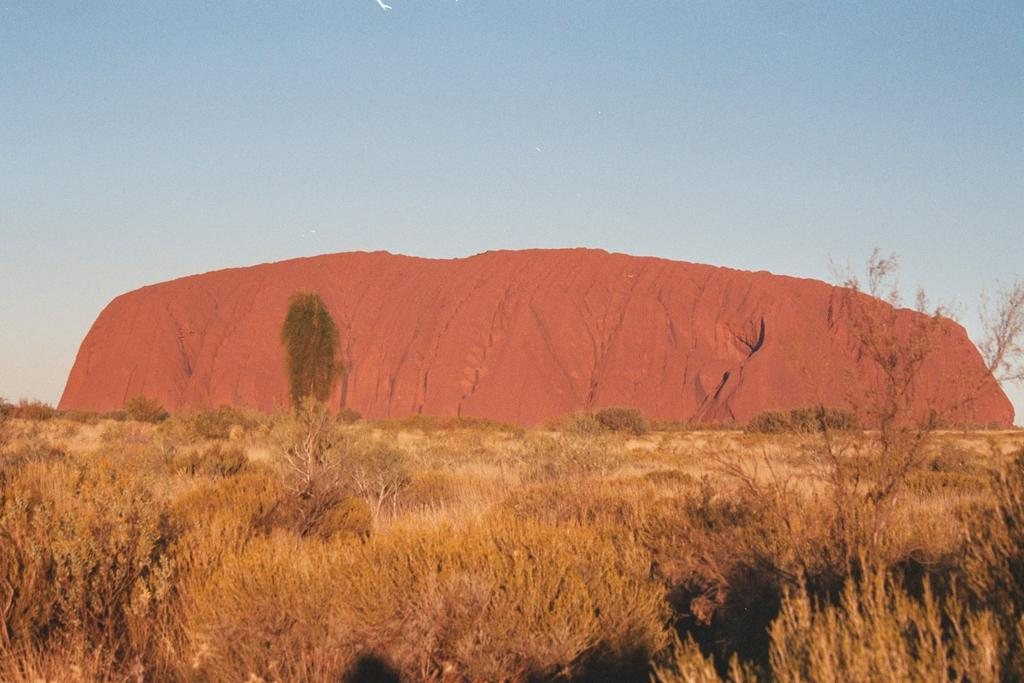What type of vegetation can be seen in the image? There are trees in the image. What part of the natural environment is visible in the image? The sky is visible in the background of the image. What type of property is being sold in the image? There is no property being sold in the image; it only features trees and the sky. Can you see a crown on top of any of the trees in the image? There is no crown present on any of the trees in the image. 